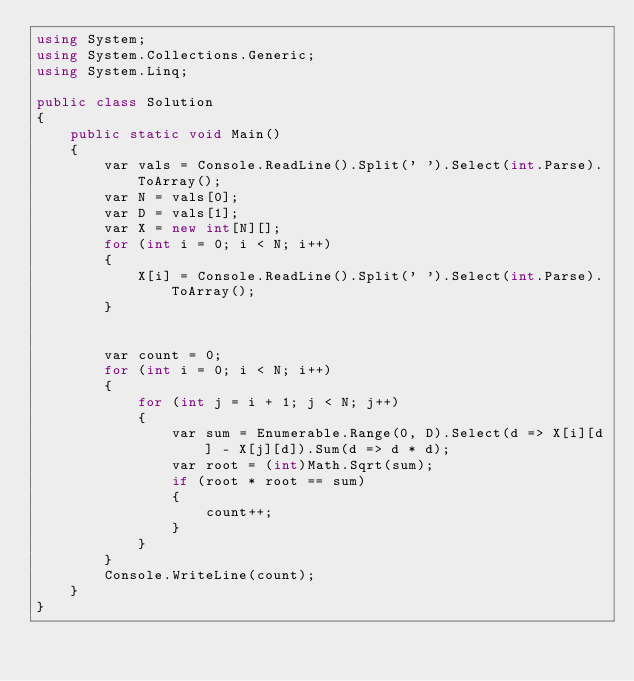Convert code to text. <code><loc_0><loc_0><loc_500><loc_500><_C#_>using System;
using System.Collections.Generic;
using System.Linq;

public class Solution
{
    public static void Main()
    {
        var vals = Console.ReadLine().Split(' ').Select(int.Parse).ToArray();
        var N = vals[0];
        var D = vals[1];
        var X = new int[N][];
        for (int i = 0; i < N; i++)
        {
            X[i] = Console.ReadLine().Split(' ').Select(int.Parse).ToArray();
        }


        var count = 0;
        for (int i = 0; i < N; i++)
        {
            for (int j = i + 1; j < N; j++)
            {
                var sum = Enumerable.Range(0, D).Select(d => X[i][d] - X[j][d]).Sum(d => d * d);
                var root = (int)Math.Sqrt(sum);
                if (root * root == sum)
                {
                    count++;
                }
            }
        }
        Console.WriteLine(count);
    }
}</code> 